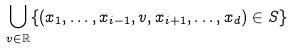Convert formula to latex. <formula><loc_0><loc_0><loc_500><loc_500>\bigcup _ { v \in \mathbb { R } } \{ ( x _ { 1 } , \dots , x _ { i - 1 } , v , x _ { i + 1 } , \dots , x _ { d } ) \in S \}</formula> 